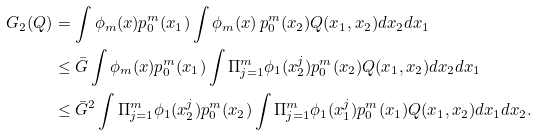Convert formula to latex. <formula><loc_0><loc_0><loc_500><loc_500>G _ { 2 } ( Q ) & = \int \phi _ { m } ( x ) p _ { 0 } ^ { m } ( x _ { 1 } ) \int \phi _ { m } ( x ) \, p _ { 0 } ^ { m } ( x _ { 2 } ) Q ( x _ { 1 } , x _ { 2 } ) d x _ { 2 } d x _ { 1 } \\ & \leq \bar { G } \int \phi _ { m } ( x ) p _ { 0 } ^ { m } ( x _ { 1 } ) \int \Pi _ { j = 1 } ^ { m } \phi _ { 1 } ( x ^ { j } _ { 2 } ) p _ { 0 } ^ { m } ( x _ { 2 } ) Q ( x _ { 1 } , x _ { 2 } ) d x _ { 2 } d x _ { 1 } \\ & \leq \bar { G } ^ { 2 } \int \Pi _ { j = 1 } ^ { m } \phi _ { 1 } ( x ^ { j } _ { 2 } ) p _ { 0 } ^ { m } ( x _ { 2 } ) \int \Pi _ { j = 1 } ^ { m } \phi _ { 1 } ( x ^ { j } _ { 1 } ) p _ { 0 } ^ { m } ( x _ { 1 } ) Q ( x _ { 1 } , x _ { 2 } ) d x _ { 1 } d x _ { 2 } .</formula> 